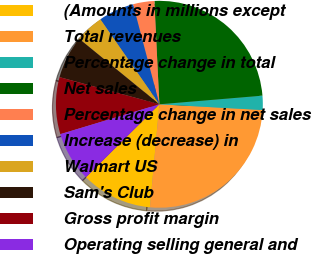Convert chart to OTSL. <chart><loc_0><loc_0><loc_500><loc_500><pie_chart><fcel>(Amounts in millions except<fcel>Total revenues<fcel>Percentage change in total<fcel>Net sales<fcel>Percentage change in net sales<fcel>Increase (decrease) in<fcel>Walmart US<fcel>Sam's Club<fcel>Gross profit margin<fcel>Operating selling general and<nl><fcel>11.11%<fcel>25.56%<fcel>2.22%<fcel>24.44%<fcel>3.33%<fcel>5.56%<fcel>4.44%<fcel>6.67%<fcel>8.89%<fcel>7.78%<nl></chart> 